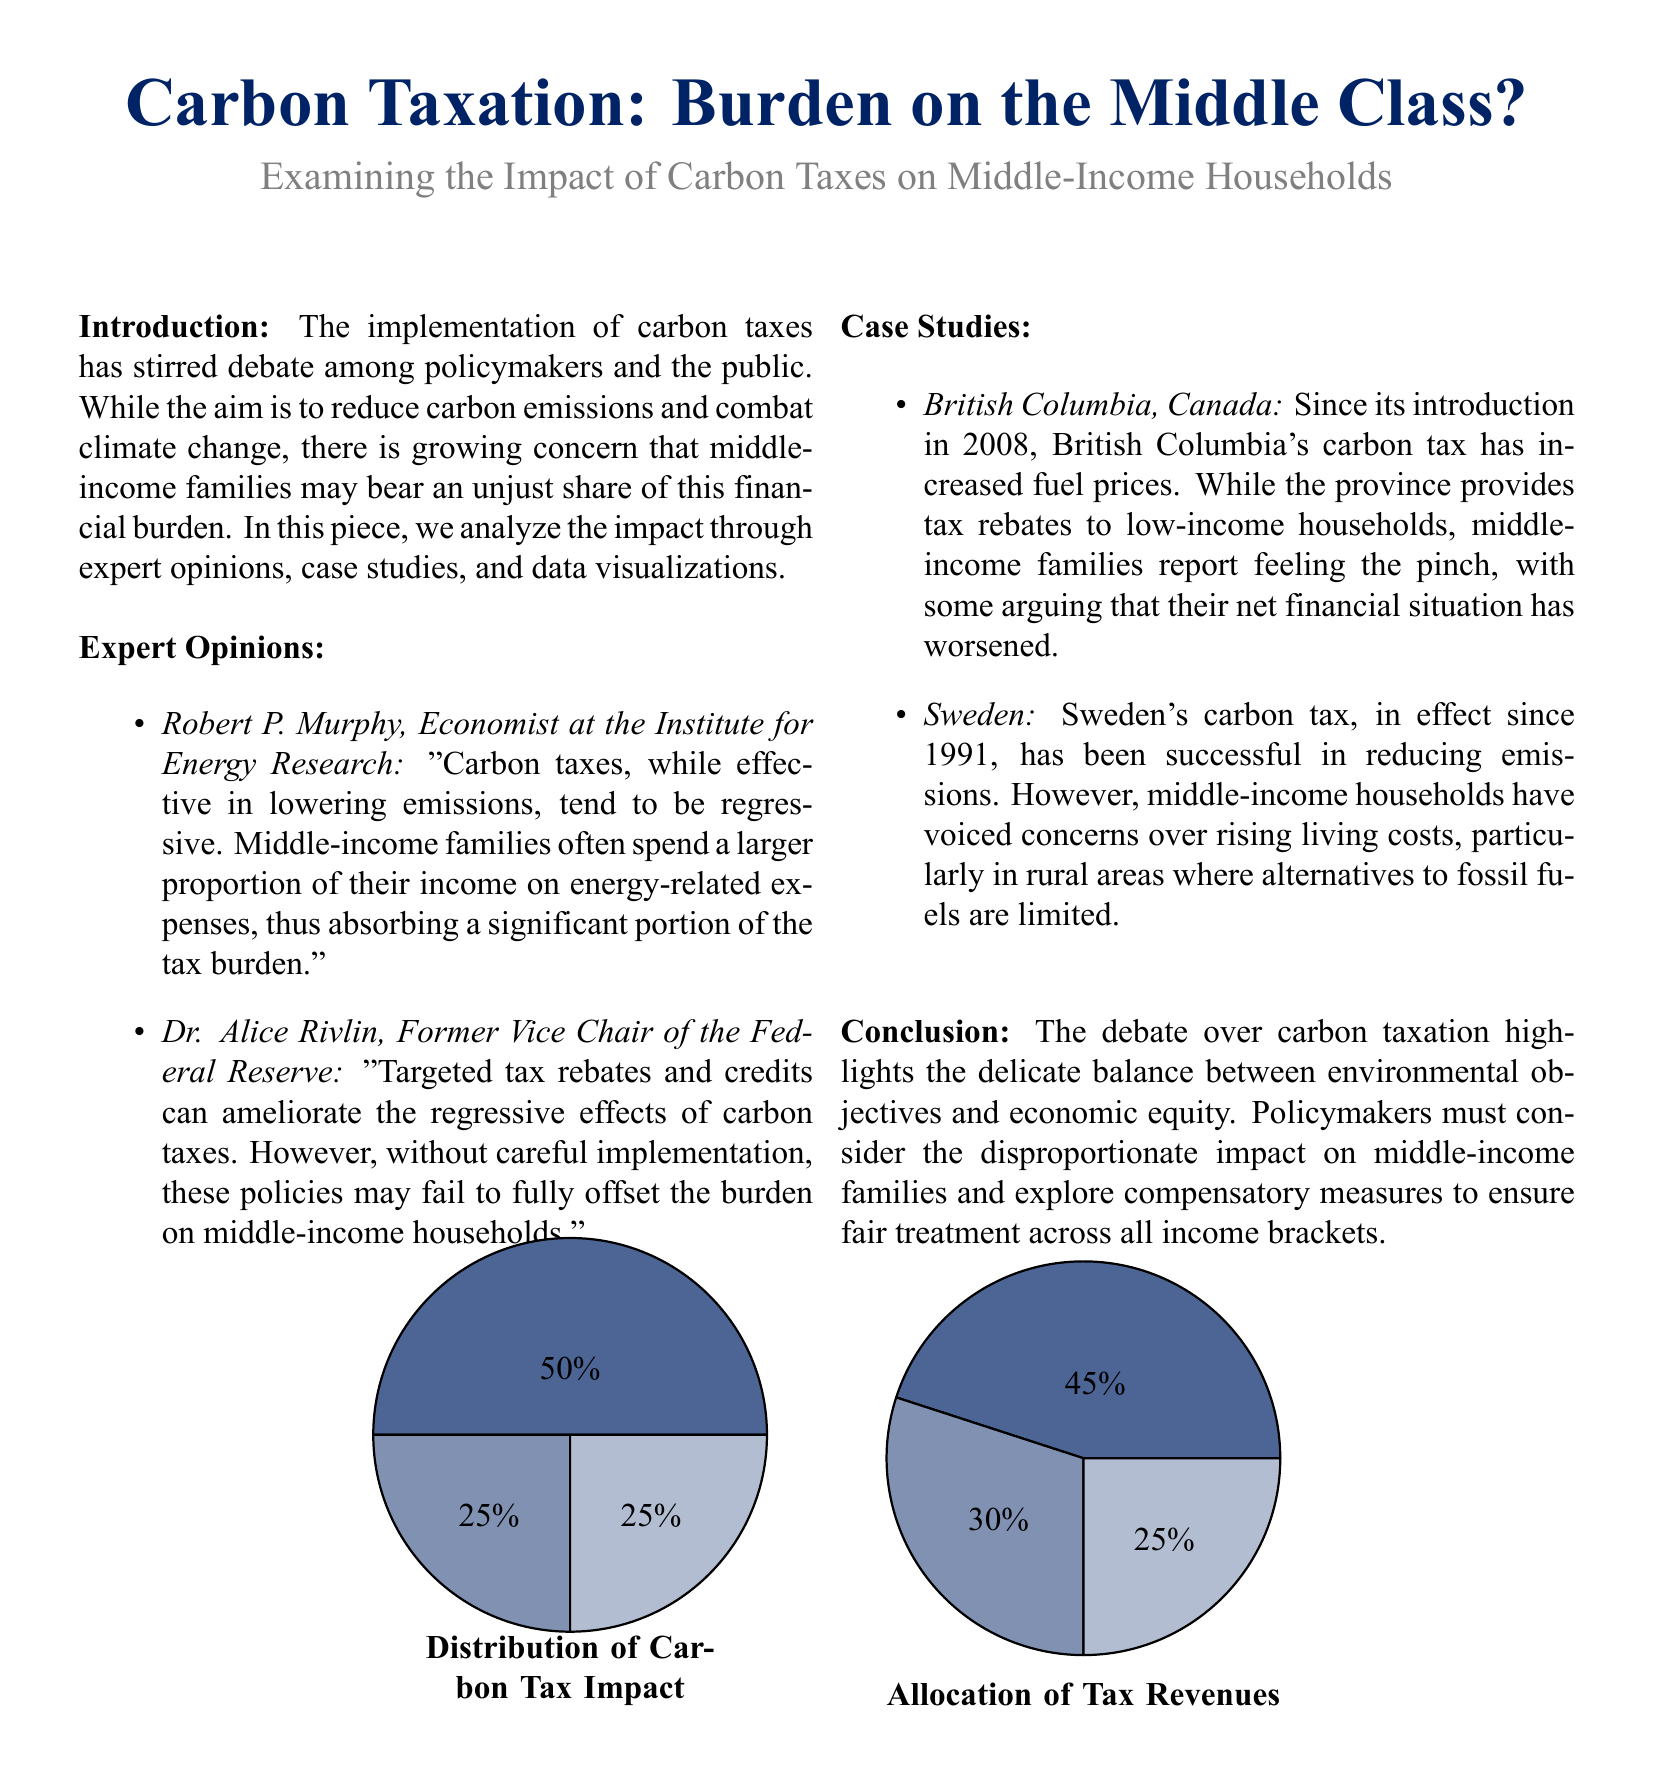What is the title of the document? The title is prominently displayed at the top of the document.
Answer: Carbon Taxation: Burden on the Middle Class? Who is the economist mentioned in the expert opinions? The document lists Robert P. Murphy as an economist at the Institute for Energy Research.
Answer: Robert P. Murphy What year did British Columbia introduce its carbon tax? The introduction year is explicitly stated in the case study section of the document.
Answer: 2008 What percentage of the carbon tax impact affects middle-income households? The document includes a pie chart showing the percentage distribution of the carbon tax impact on various income groups.
Answer: 50 What is the percentage allocation of tax revenues for environmental projects? The pie chart outlines how the tax revenues are distributed among various uses.
Answer: 45 Which region's carbon tax has been in effect since 1991? The document provides a case study regarding Sweden, which has implemented its carbon tax since this year.
Answer: Sweden Which expert suggests targeted tax rebates as a solution? The document mentions Dr. Alice Rivlin discussing compensatory measures for middle-income families.
Answer: Dr. Alice Rivlin What is the color scheme used in the pie charts? The document describes the colors used in the pie charts in the TikZ portion.
Answer: Conservative blue How many components are shown in the allocation of tax revenues pie chart? The document contains a pie chart that illustrates the distribution of tax revenues into different categories.
Answer: 3 